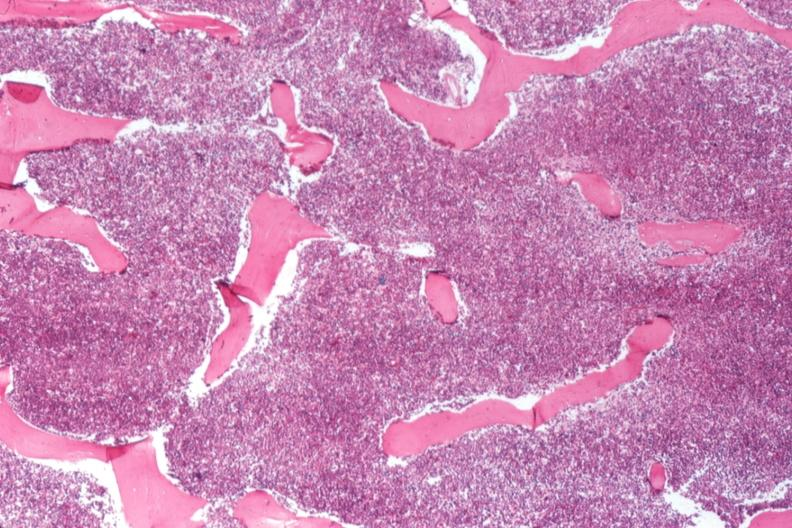s hematologic present?
Answer the question using a single word or phrase. Yes 